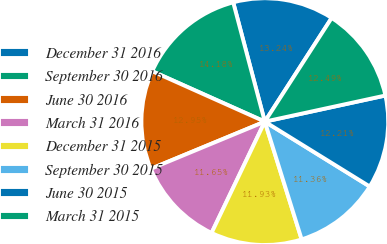Convert chart to OTSL. <chart><loc_0><loc_0><loc_500><loc_500><pie_chart><fcel>December 31 2016<fcel>September 30 2016<fcel>June 30 2016<fcel>March 31 2016<fcel>December 31 2015<fcel>September 30 2015<fcel>June 30 2015<fcel>March 31 2015<nl><fcel>13.24%<fcel>14.18%<fcel>12.95%<fcel>11.65%<fcel>11.93%<fcel>11.36%<fcel>12.21%<fcel>12.49%<nl></chart> 